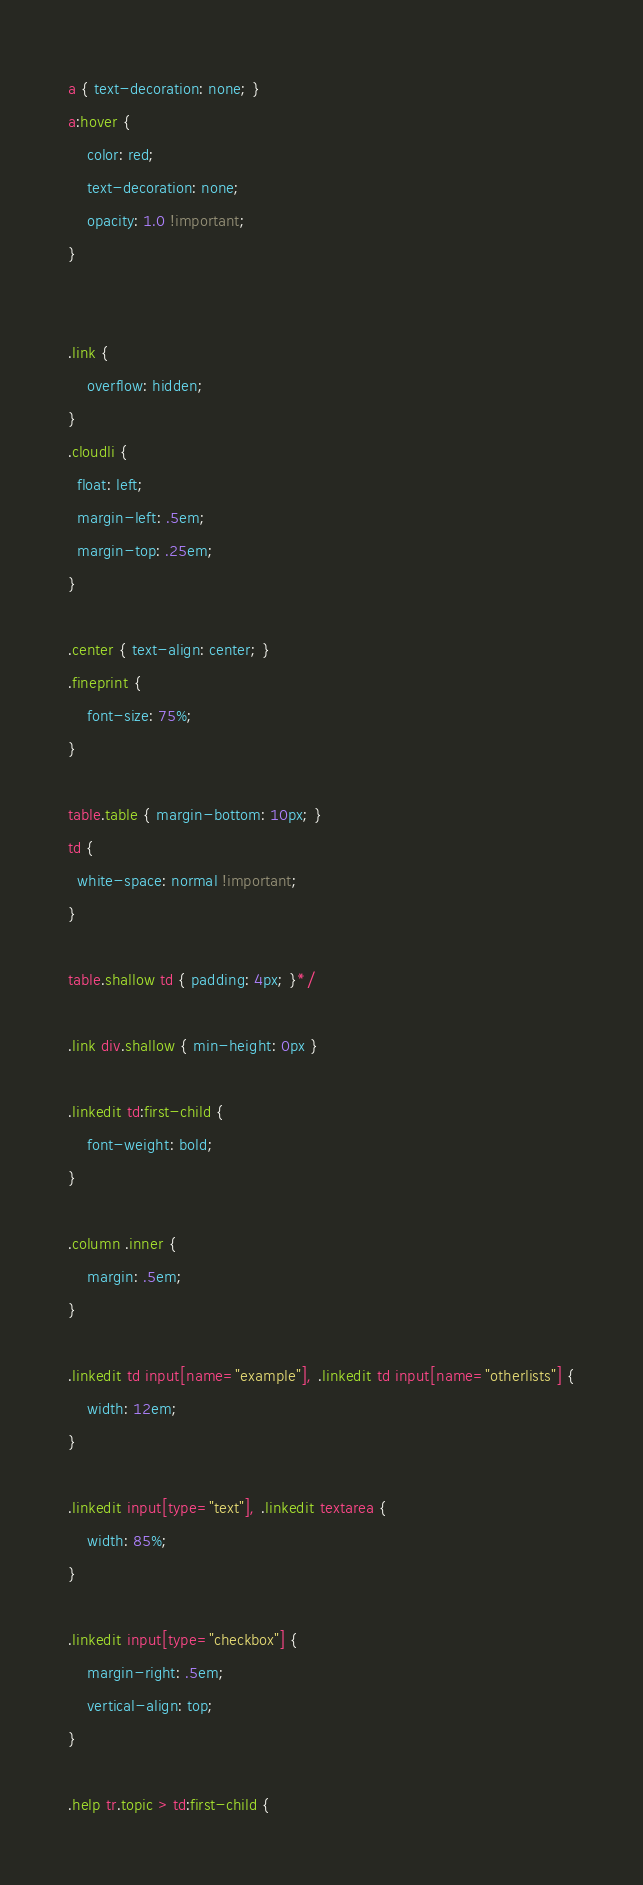Convert code to text. <code><loc_0><loc_0><loc_500><loc_500><_CSS_>a { text-decoration: none; }
a:hover {
    color: red;
    text-decoration: none;
    opacity: 1.0 !important;
}


.link {
    overflow: hidden;
}
.cloudli {
  float: left;
  margin-left: .5em;
  margin-top: .25em;
}

.center { text-align: center; }
.fineprint {
    font-size: 75%;
}

table.table { margin-bottom: 10px; }
td {
  white-space: normal !important;
}

table.shallow td { padding: 4px; }*/

.link div.shallow { min-height: 0px }

.linkedit td:first-child {
    font-weight: bold;
}

.column .inner {
    margin: .5em;
}

.linkedit td input[name="example"], .linkedit td input[name="otherlists"] {
    width: 12em;
}

.linkedit input[type="text"], .linkedit textarea {
    width: 85%;
}

.linkedit input[type="checkbox"] {
    margin-right: .5em;
    vertical-align: top;
}

.help tr.topic > td:first-child {</code> 